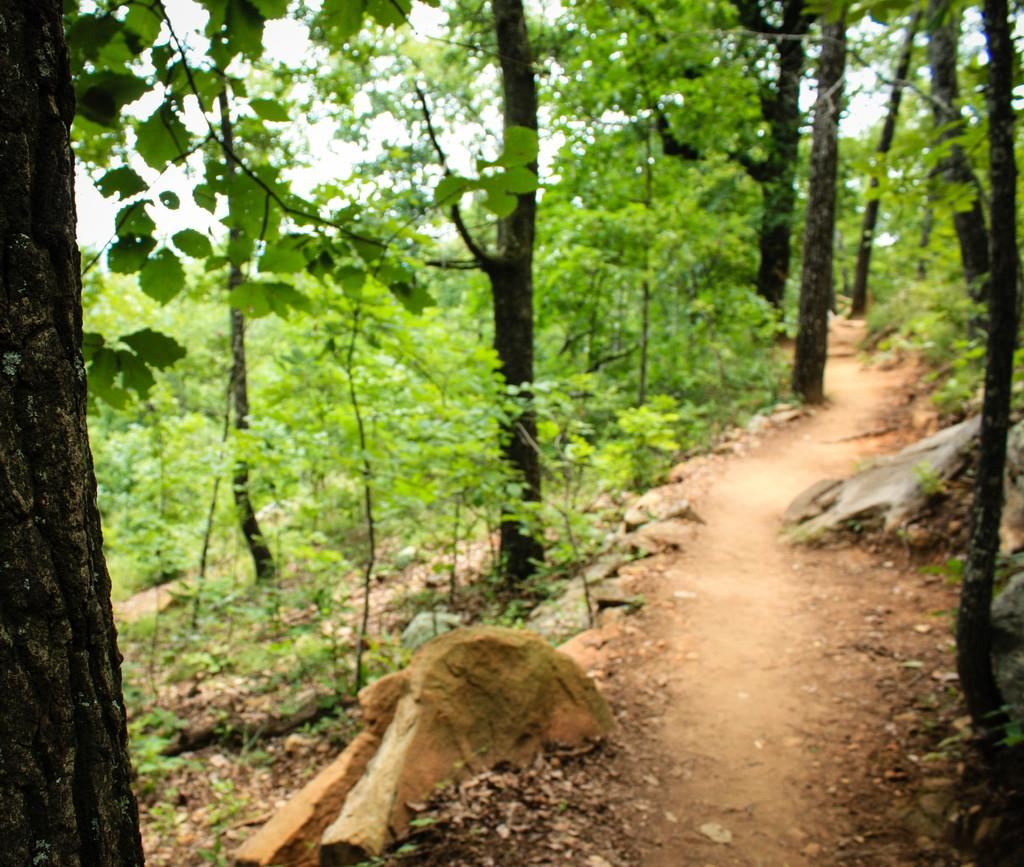What type of living organisms can be seen in the image? Plants and trees are visible in the image. What part of the natural environment is visible in the image? The sky is visible in the background of the image. What type of pain is the plant experiencing in the image? There is no indication in the image that the plants are experiencing any pain, as plants do not have the ability to feel pain. 